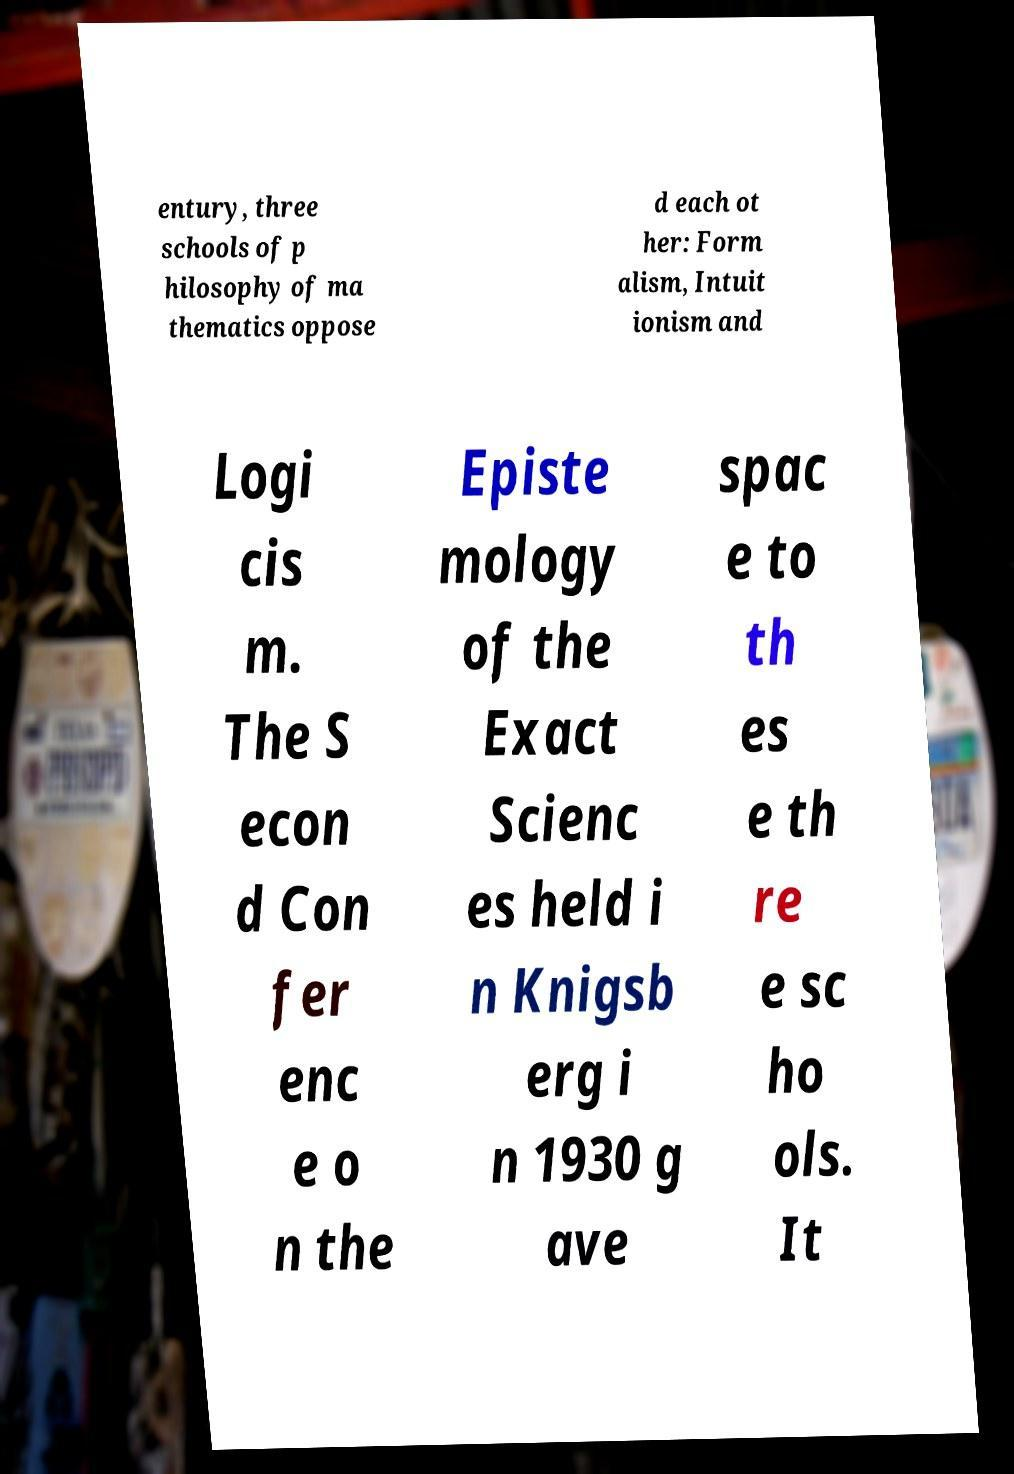Please identify and transcribe the text found in this image. entury, three schools of p hilosophy of ma thematics oppose d each ot her: Form alism, Intuit ionism and Logi cis m. The S econ d Con fer enc e o n the Episte mology of the Exact Scienc es held i n Knigsb erg i n 1930 g ave spac e to th es e th re e sc ho ols. It 